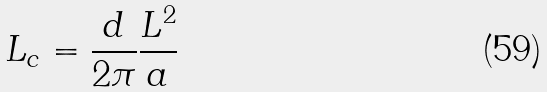Convert formula to latex. <formula><loc_0><loc_0><loc_500><loc_500>L _ { c } = \frac { d } { 2 \pi } \frac { L ^ { 2 } } { a }</formula> 